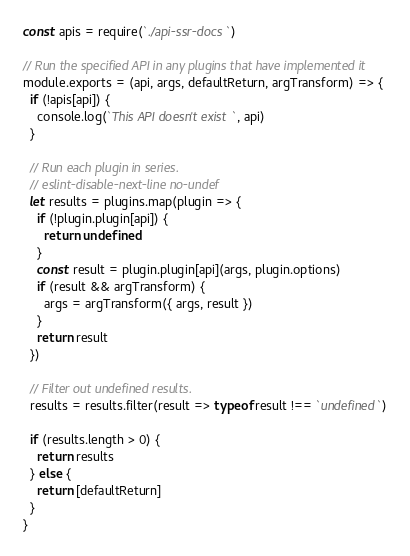<code> <loc_0><loc_0><loc_500><loc_500><_JavaScript_>const apis = require(`./api-ssr-docs`)

// Run the specified API in any plugins that have implemented it
module.exports = (api, args, defaultReturn, argTransform) => {
  if (!apis[api]) {
    console.log(`This API doesn't exist`, api)
  }

  // Run each plugin in series.
  // eslint-disable-next-line no-undef
  let results = plugins.map(plugin => {
    if (!plugin.plugin[api]) {
      return undefined
    }
    const result = plugin.plugin[api](args, plugin.options)
    if (result && argTransform) {
      args = argTransform({ args, result })
    }
    return result
  })

  // Filter out undefined results.
  results = results.filter(result => typeof result !== `undefined`)

  if (results.length > 0) {
    return results
  } else {
    return [defaultReturn]
  }
}
</code> 